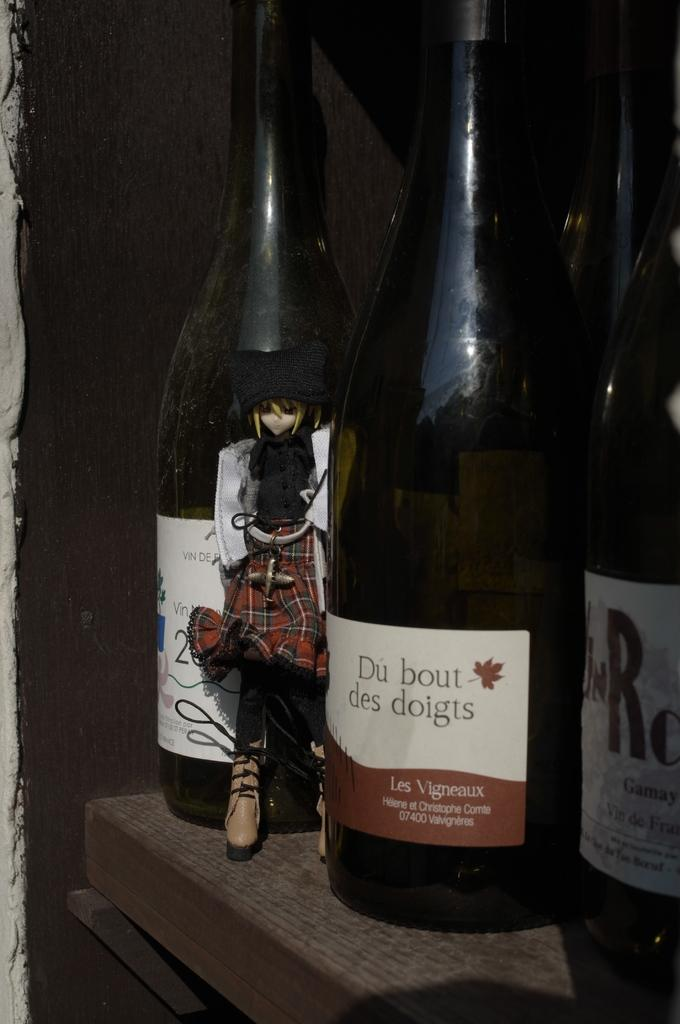<image>
Relay a brief, clear account of the picture shown. A bottle of Du bout des doigts on a shelf with several other wine bottles. 